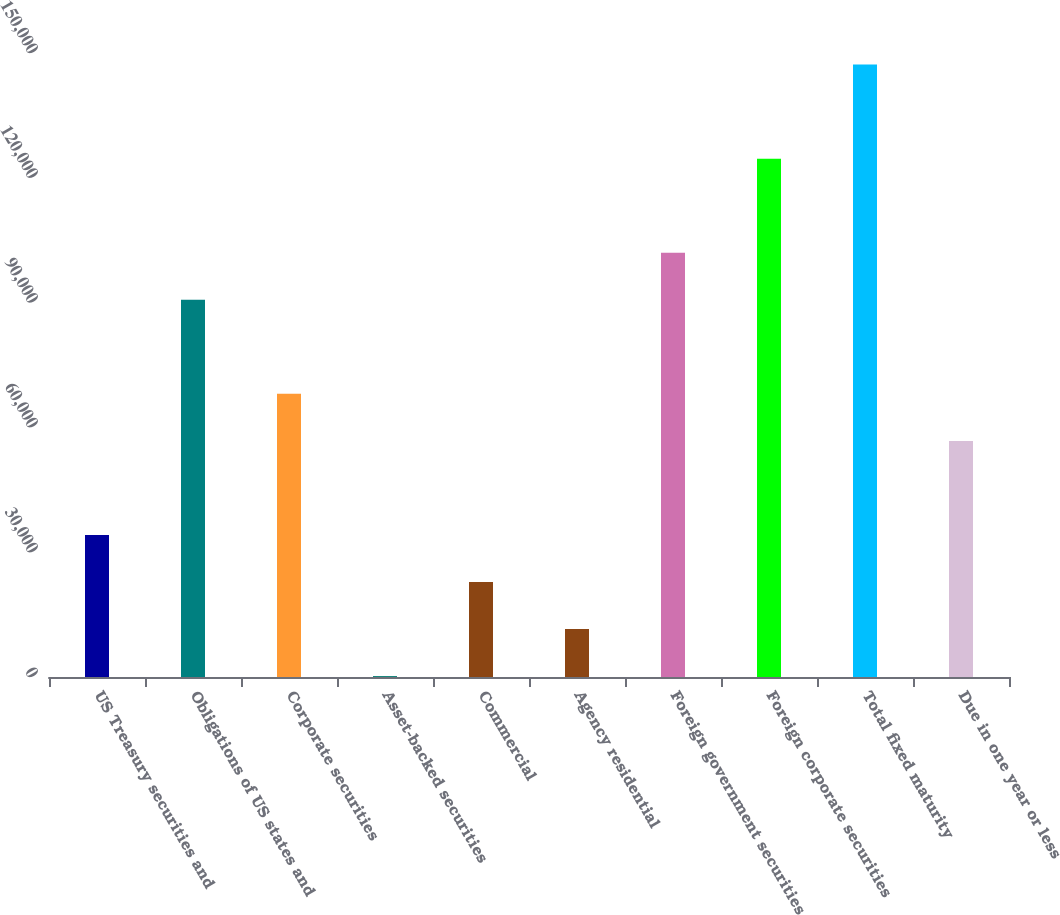Convert chart to OTSL. <chart><loc_0><loc_0><loc_500><loc_500><bar_chart><fcel>US Treasury securities and<fcel>Obligations of US states and<fcel>Corporate securities<fcel>Asset-backed securities<fcel>Commercial<fcel>Agency residential<fcel>Foreign government securities<fcel>Foreign corporate securities<fcel>Total fixed maturity<fcel>Due in one year or less<nl><fcel>34139.6<fcel>90680.6<fcel>68064.2<fcel>215<fcel>22831.4<fcel>11523.2<fcel>101989<fcel>124605<fcel>147222<fcel>56756<nl></chart> 